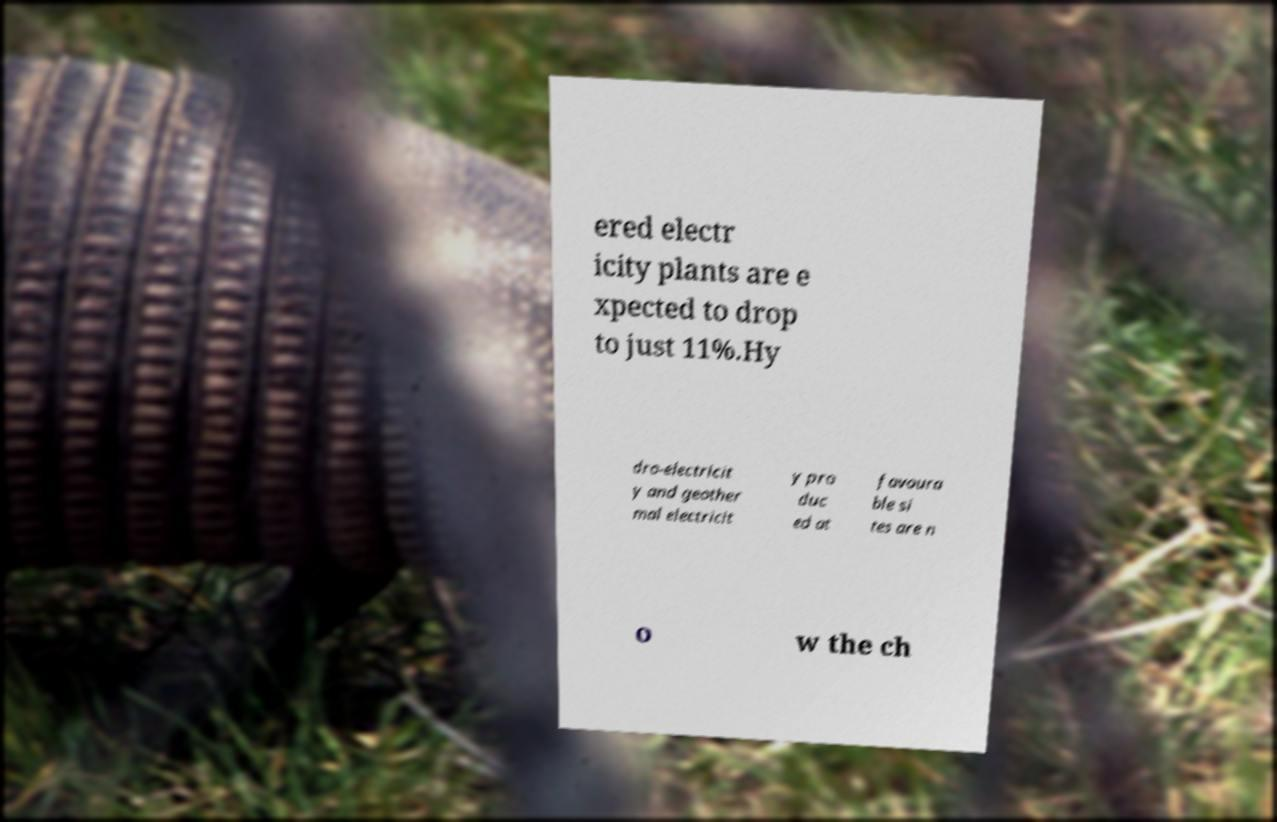Can you accurately transcribe the text from the provided image for me? ered electr icity plants are e xpected to drop to just 11%.Hy dro-electricit y and geother mal electricit y pro duc ed at favoura ble si tes are n o w the ch 